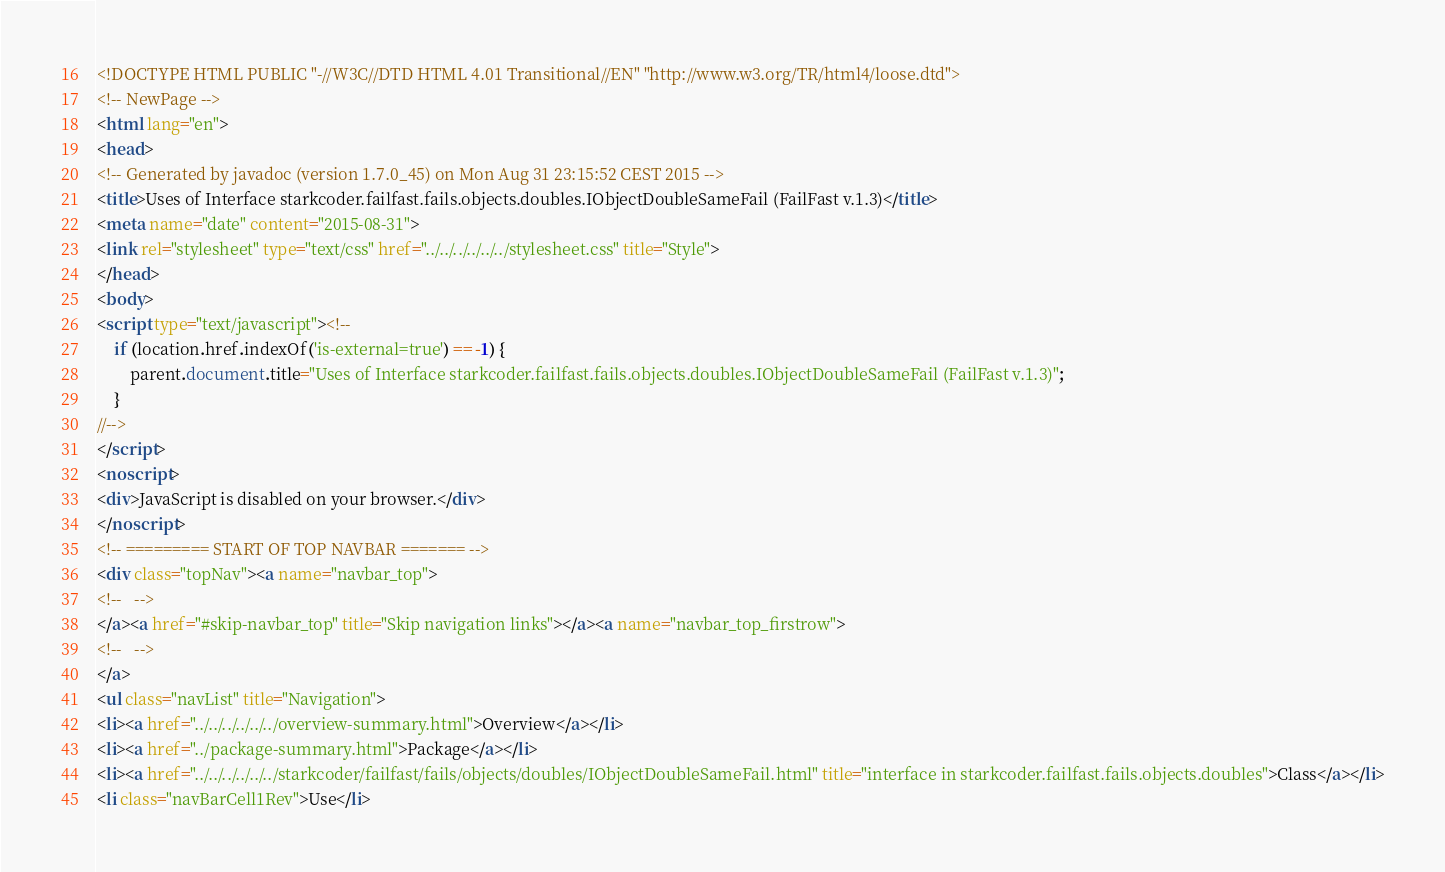Convert code to text. <code><loc_0><loc_0><loc_500><loc_500><_HTML_><!DOCTYPE HTML PUBLIC "-//W3C//DTD HTML 4.01 Transitional//EN" "http://www.w3.org/TR/html4/loose.dtd">
<!-- NewPage -->
<html lang="en">
<head>
<!-- Generated by javadoc (version 1.7.0_45) on Mon Aug 31 23:15:52 CEST 2015 -->
<title>Uses of Interface starkcoder.failfast.fails.objects.doubles.IObjectDoubleSameFail (FailFast v.1.3)</title>
<meta name="date" content="2015-08-31">
<link rel="stylesheet" type="text/css" href="../../../../../../stylesheet.css" title="Style">
</head>
<body>
<script type="text/javascript"><!--
    if (location.href.indexOf('is-external=true') == -1) {
        parent.document.title="Uses of Interface starkcoder.failfast.fails.objects.doubles.IObjectDoubleSameFail (FailFast v.1.3)";
    }
//-->
</script>
<noscript>
<div>JavaScript is disabled on your browser.</div>
</noscript>
<!-- ========= START OF TOP NAVBAR ======= -->
<div class="topNav"><a name="navbar_top">
<!--   -->
</a><a href="#skip-navbar_top" title="Skip navigation links"></a><a name="navbar_top_firstrow">
<!--   -->
</a>
<ul class="navList" title="Navigation">
<li><a href="../../../../../../overview-summary.html">Overview</a></li>
<li><a href="../package-summary.html">Package</a></li>
<li><a href="../../../../../../starkcoder/failfast/fails/objects/doubles/IObjectDoubleSameFail.html" title="interface in starkcoder.failfast.fails.objects.doubles">Class</a></li>
<li class="navBarCell1Rev">Use</li></code> 